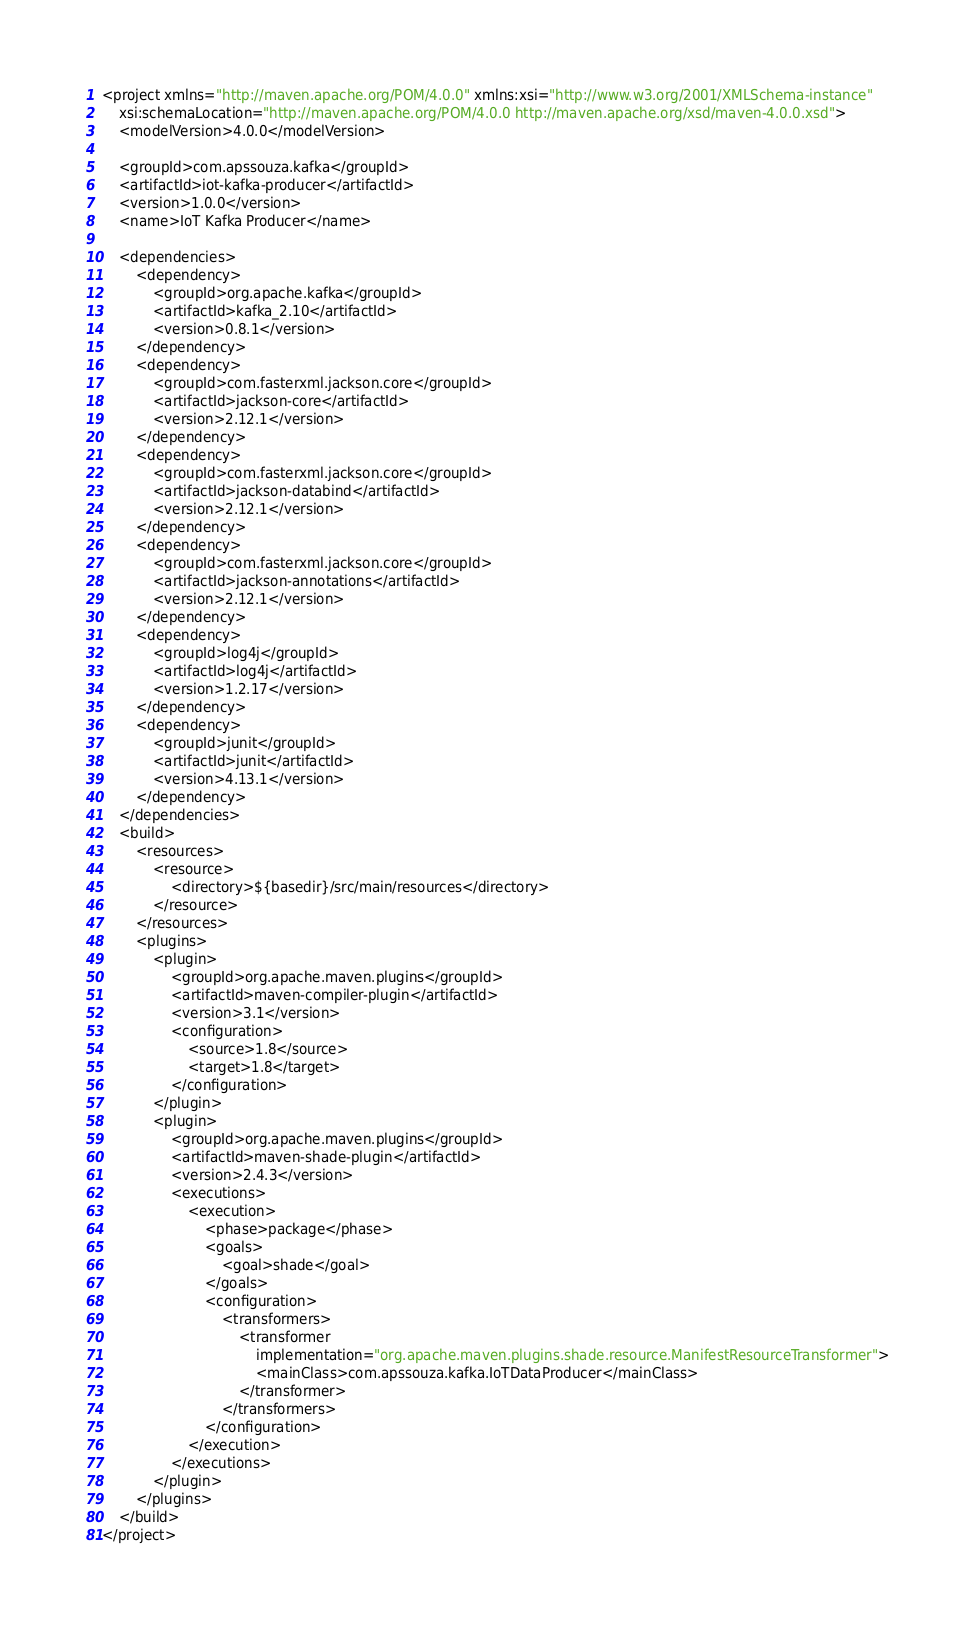Convert code to text. <code><loc_0><loc_0><loc_500><loc_500><_XML_><project xmlns="http://maven.apache.org/POM/4.0.0" xmlns:xsi="http://www.w3.org/2001/XMLSchema-instance"
	xsi:schemaLocation="http://maven.apache.org/POM/4.0.0 http://maven.apache.org/xsd/maven-4.0.0.xsd">
	<modelVersion>4.0.0</modelVersion>

	<groupId>com.apssouza.kafka</groupId>
	<artifactId>iot-kafka-producer</artifactId>
	<version>1.0.0</version>
	<name>IoT Kafka Producer</name>

	<dependencies>
		<dependency>
			<groupId>org.apache.kafka</groupId>
			<artifactId>kafka_2.10</artifactId>
			<version>0.8.1</version>
		</dependency>
		<dependency>
			<groupId>com.fasterxml.jackson.core</groupId>
			<artifactId>jackson-core</artifactId>
			<version>2.12.1</version>
		</dependency>
		<dependency>
			<groupId>com.fasterxml.jackson.core</groupId>
			<artifactId>jackson-databind</artifactId>
			<version>2.12.1</version>
		</dependency>
		<dependency>
			<groupId>com.fasterxml.jackson.core</groupId>
			<artifactId>jackson-annotations</artifactId>
			<version>2.12.1</version>
		</dependency>
		<dependency>
			<groupId>log4j</groupId>
			<artifactId>log4j</artifactId>
			<version>1.2.17</version>
		</dependency>
		<dependency>
			<groupId>junit</groupId>
			<artifactId>junit</artifactId>
			<version>4.13.1</version>
		</dependency>
	</dependencies>
	<build>
		<resources>
			<resource>
				<directory>${basedir}/src/main/resources</directory>
			</resource>
		</resources>
		<plugins>
			<plugin>
				<groupId>org.apache.maven.plugins</groupId>
				<artifactId>maven-compiler-plugin</artifactId>
				<version>3.1</version>
				<configuration>
					<source>1.8</source>
					<target>1.8</target>
				</configuration>
			</plugin>
			<plugin>
				<groupId>org.apache.maven.plugins</groupId>
				<artifactId>maven-shade-plugin</artifactId>
				<version>2.4.3</version>
				<executions>
					<execution>
						<phase>package</phase>
						<goals>
							<goal>shade</goal>
						</goals>
						<configuration>
							<transformers>
								<transformer
									implementation="org.apache.maven.plugins.shade.resource.ManifestResourceTransformer">
									<mainClass>com.apssouza.kafka.IoTDataProducer</mainClass>
								</transformer>
							</transformers>
						</configuration>
					</execution>
				</executions>
			</plugin>
		</plugins>
	</build>
</project></code> 